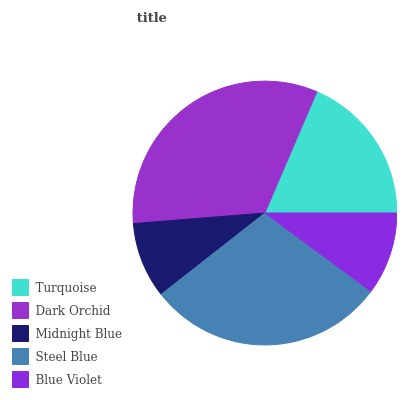Is Midnight Blue the minimum?
Answer yes or no. Yes. Is Dark Orchid the maximum?
Answer yes or no. Yes. Is Dark Orchid the minimum?
Answer yes or no. No. Is Midnight Blue the maximum?
Answer yes or no. No. Is Dark Orchid greater than Midnight Blue?
Answer yes or no. Yes. Is Midnight Blue less than Dark Orchid?
Answer yes or no. Yes. Is Midnight Blue greater than Dark Orchid?
Answer yes or no. No. Is Dark Orchid less than Midnight Blue?
Answer yes or no. No. Is Turquoise the high median?
Answer yes or no. Yes. Is Turquoise the low median?
Answer yes or no. Yes. Is Blue Violet the high median?
Answer yes or no. No. Is Midnight Blue the low median?
Answer yes or no. No. 